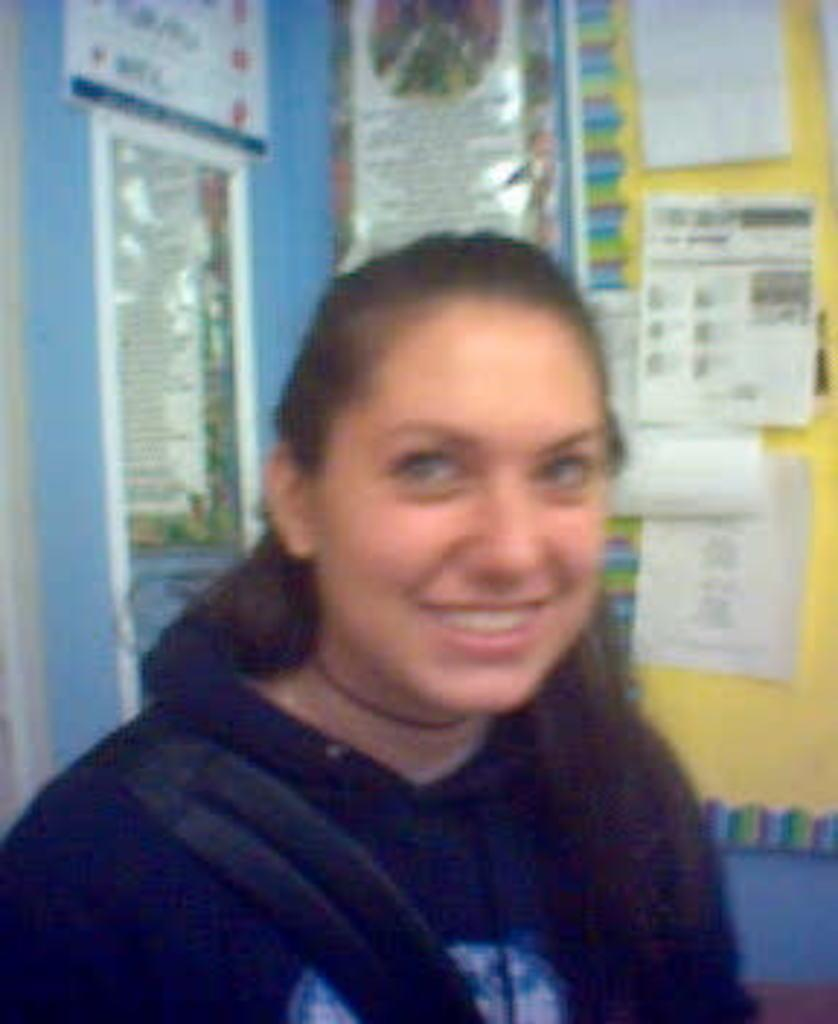What is the main subject in the foreground of the image? There is a woman in the foreground of the image. What is the woman doing in the image? The woman is standing in the image. What is the woman's facial expression in the image? The woman is smiling in the image. What can be seen in the background of the image? There is a wall in the background of the image. What is on the wall in the image? There are papers on the wall in the image. Can you see a trail leading to the woman in the image? There is no trail visible in the image; it features a woman standing in front of a wall with papers on it. Is the woman swinging on a swing in the image? No, the woman is standing, not swinging on a swing, in the image. 